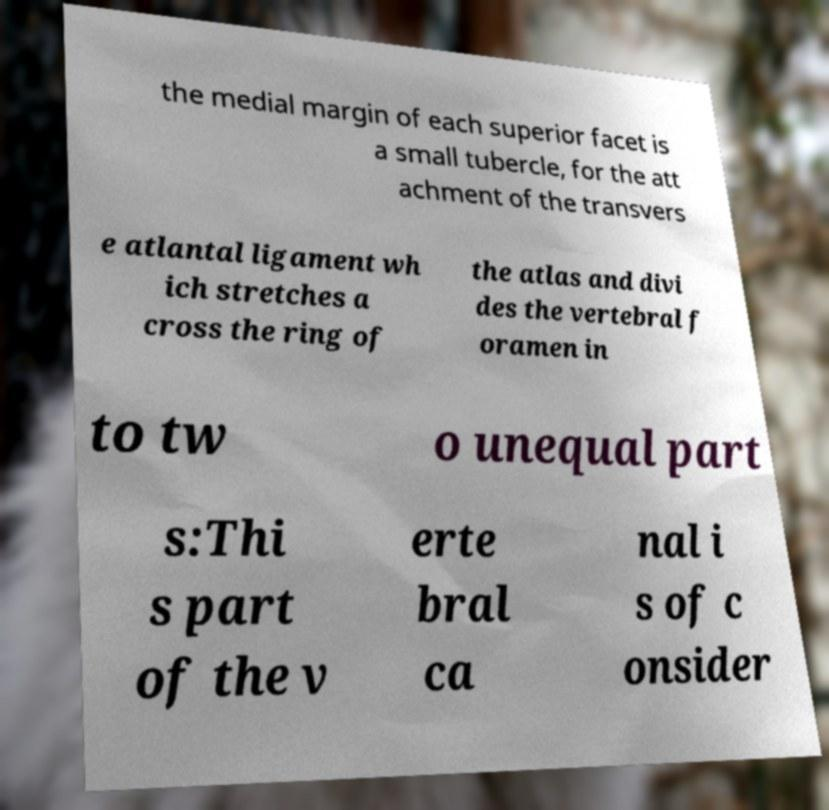There's text embedded in this image that I need extracted. Can you transcribe it verbatim? the medial margin of each superior facet is a small tubercle, for the att achment of the transvers e atlantal ligament wh ich stretches a cross the ring of the atlas and divi des the vertebral f oramen in to tw o unequal part s:Thi s part of the v erte bral ca nal i s of c onsider 